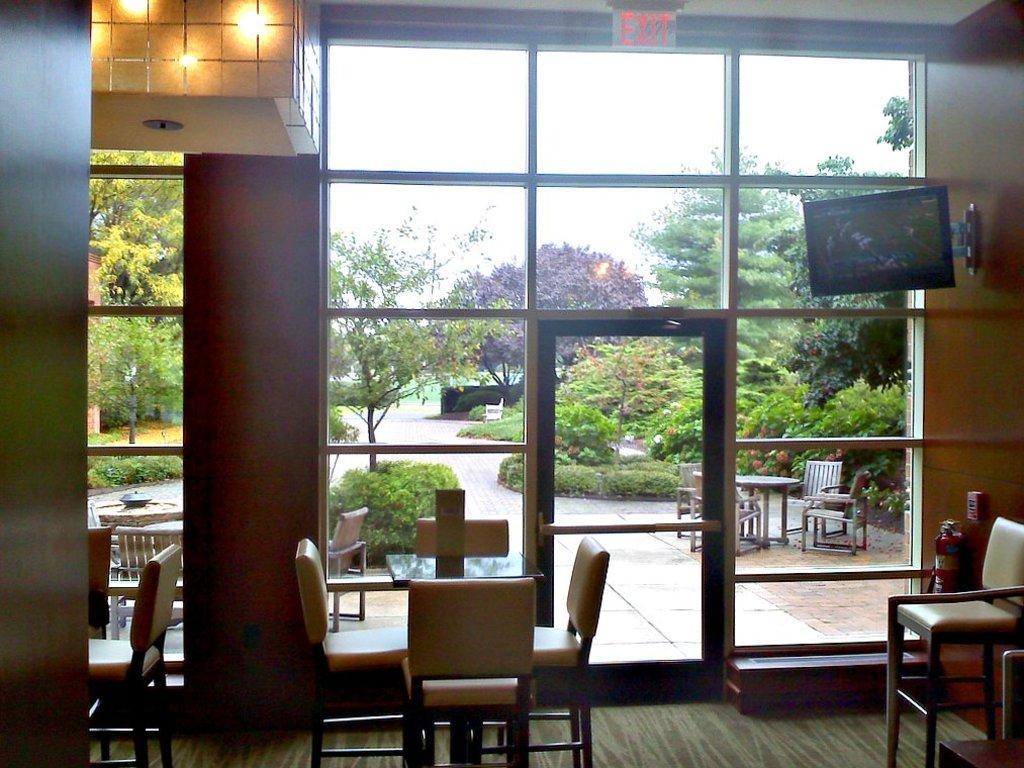How would you summarize this image in a sentence or two? In this image I can see many chairs inside the building. To the right there is a fire extinguisher and the screen. I can see the exit board and the light in the top. There is a glass in the back. Through the glass I can see few more chairs, tables, many plants and the sky. 